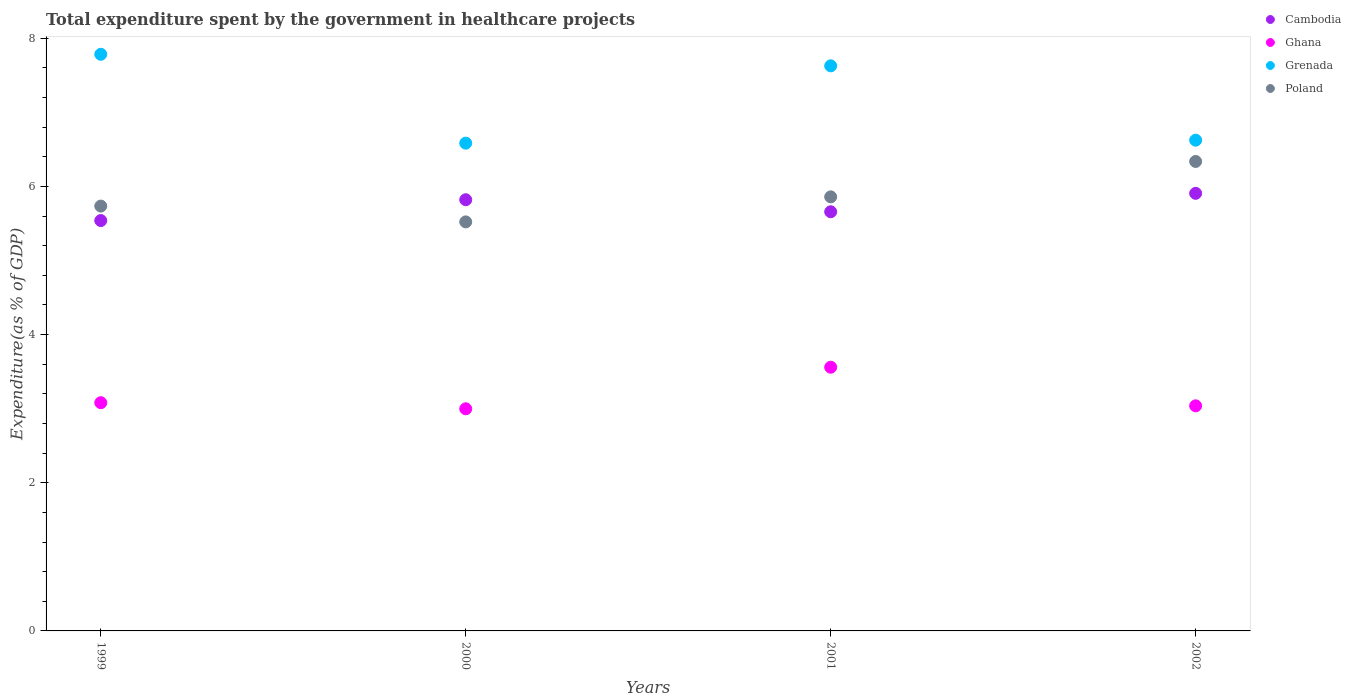How many different coloured dotlines are there?
Your answer should be compact. 4. What is the total expenditure spent by the government in healthcare projects in Ghana in 2001?
Give a very brief answer. 3.56. Across all years, what is the maximum total expenditure spent by the government in healthcare projects in Poland?
Provide a short and direct response. 6.34. Across all years, what is the minimum total expenditure spent by the government in healthcare projects in Poland?
Your answer should be very brief. 5.52. In which year was the total expenditure spent by the government in healthcare projects in Ghana minimum?
Provide a short and direct response. 2000. What is the total total expenditure spent by the government in healthcare projects in Cambodia in the graph?
Keep it short and to the point. 22.92. What is the difference between the total expenditure spent by the government in healthcare projects in Poland in 2001 and that in 2002?
Offer a terse response. -0.48. What is the difference between the total expenditure spent by the government in healthcare projects in Ghana in 1999 and the total expenditure spent by the government in healthcare projects in Grenada in 2000?
Your response must be concise. -3.5. What is the average total expenditure spent by the government in healthcare projects in Ghana per year?
Offer a terse response. 3.17. In the year 2000, what is the difference between the total expenditure spent by the government in healthcare projects in Ghana and total expenditure spent by the government in healthcare projects in Poland?
Make the answer very short. -2.52. In how many years, is the total expenditure spent by the government in healthcare projects in Poland greater than 6.4 %?
Provide a short and direct response. 0. What is the ratio of the total expenditure spent by the government in healthcare projects in Cambodia in 1999 to that in 2001?
Offer a terse response. 0.98. What is the difference between the highest and the second highest total expenditure spent by the government in healthcare projects in Grenada?
Your response must be concise. 0.16. What is the difference between the highest and the lowest total expenditure spent by the government in healthcare projects in Grenada?
Offer a terse response. 1.2. Is it the case that in every year, the sum of the total expenditure spent by the government in healthcare projects in Ghana and total expenditure spent by the government in healthcare projects in Cambodia  is greater than the total expenditure spent by the government in healthcare projects in Poland?
Provide a short and direct response. Yes. Does the total expenditure spent by the government in healthcare projects in Ghana monotonically increase over the years?
Make the answer very short. No. How many dotlines are there?
Your answer should be very brief. 4. How many years are there in the graph?
Your answer should be very brief. 4. What is the difference between two consecutive major ticks on the Y-axis?
Keep it short and to the point. 2. Does the graph contain grids?
Your response must be concise. No. How are the legend labels stacked?
Provide a succinct answer. Vertical. What is the title of the graph?
Provide a succinct answer. Total expenditure spent by the government in healthcare projects. What is the label or title of the Y-axis?
Make the answer very short. Expenditure(as % of GDP). What is the Expenditure(as % of GDP) in Cambodia in 1999?
Make the answer very short. 5.54. What is the Expenditure(as % of GDP) in Ghana in 1999?
Your answer should be very brief. 3.08. What is the Expenditure(as % of GDP) in Grenada in 1999?
Your response must be concise. 7.78. What is the Expenditure(as % of GDP) of Poland in 1999?
Provide a succinct answer. 5.73. What is the Expenditure(as % of GDP) in Cambodia in 2000?
Offer a very short reply. 5.82. What is the Expenditure(as % of GDP) of Ghana in 2000?
Make the answer very short. 3. What is the Expenditure(as % of GDP) in Grenada in 2000?
Make the answer very short. 6.58. What is the Expenditure(as % of GDP) of Poland in 2000?
Provide a succinct answer. 5.52. What is the Expenditure(as % of GDP) in Cambodia in 2001?
Your response must be concise. 5.66. What is the Expenditure(as % of GDP) of Ghana in 2001?
Offer a terse response. 3.56. What is the Expenditure(as % of GDP) of Grenada in 2001?
Your answer should be very brief. 7.63. What is the Expenditure(as % of GDP) of Poland in 2001?
Give a very brief answer. 5.86. What is the Expenditure(as % of GDP) of Cambodia in 2002?
Offer a very short reply. 5.91. What is the Expenditure(as % of GDP) of Ghana in 2002?
Your response must be concise. 3.04. What is the Expenditure(as % of GDP) of Grenada in 2002?
Your answer should be very brief. 6.62. What is the Expenditure(as % of GDP) of Poland in 2002?
Your answer should be very brief. 6.34. Across all years, what is the maximum Expenditure(as % of GDP) in Cambodia?
Offer a terse response. 5.91. Across all years, what is the maximum Expenditure(as % of GDP) in Ghana?
Keep it short and to the point. 3.56. Across all years, what is the maximum Expenditure(as % of GDP) of Grenada?
Keep it short and to the point. 7.78. Across all years, what is the maximum Expenditure(as % of GDP) of Poland?
Keep it short and to the point. 6.34. Across all years, what is the minimum Expenditure(as % of GDP) of Cambodia?
Your response must be concise. 5.54. Across all years, what is the minimum Expenditure(as % of GDP) in Ghana?
Give a very brief answer. 3. Across all years, what is the minimum Expenditure(as % of GDP) in Grenada?
Keep it short and to the point. 6.58. Across all years, what is the minimum Expenditure(as % of GDP) in Poland?
Keep it short and to the point. 5.52. What is the total Expenditure(as % of GDP) in Cambodia in the graph?
Make the answer very short. 22.92. What is the total Expenditure(as % of GDP) in Ghana in the graph?
Your answer should be compact. 12.68. What is the total Expenditure(as % of GDP) of Grenada in the graph?
Offer a very short reply. 28.62. What is the total Expenditure(as % of GDP) in Poland in the graph?
Give a very brief answer. 23.45. What is the difference between the Expenditure(as % of GDP) in Cambodia in 1999 and that in 2000?
Ensure brevity in your answer.  -0.28. What is the difference between the Expenditure(as % of GDP) of Ghana in 1999 and that in 2000?
Provide a succinct answer. 0.08. What is the difference between the Expenditure(as % of GDP) of Grenada in 1999 and that in 2000?
Provide a succinct answer. 1.2. What is the difference between the Expenditure(as % of GDP) of Poland in 1999 and that in 2000?
Provide a short and direct response. 0.21. What is the difference between the Expenditure(as % of GDP) in Cambodia in 1999 and that in 2001?
Your answer should be very brief. -0.12. What is the difference between the Expenditure(as % of GDP) in Ghana in 1999 and that in 2001?
Offer a very short reply. -0.48. What is the difference between the Expenditure(as % of GDP) of Grenada in 1999 and that in 2001?
Your response must be concise. 0.16. What is the difference between the Expenditure(as % of GDP) of Poland in 1999 and that in 2001?
Your answer should be compact. -0.12. What is the difference between the Expenditure(as % of GDP) in Cambodia in 1999 and that in 2002?
Your answer should be very brief. -0.37. What is the difference between the Expenditure(as % of GDP) in Ghana in 1999 and that in 2002?
Your response must be concise. 0.04. What is the difference between the Expenditure(as % of GDP) of Grenada in 1999 and that in 2002?
Make the answer very short. 1.16. What is the difference between the Expenditure(as % of GDP) of Poland in 1999 and that in 2002?
Your answer should be very brief. -0.6. What is the difference between the Expenditure(as % of GDP) in Cambodia in 2000 and that in 2001?
Offer a terse response. 0.16. What is the difference between the Expenditure(as % of GDP) of Ghana in 2000 and that in 2001?
Provide a succinct answer. -0.56. What is the difference between the Expenditure(as % of GDP) of Grenada in 2000 and that in 2001?
Your answer should be very brief. -1.04. What is the difference between the Expenditure(as % of GDP) in Poland in 2000 and that in 2001?
Give a very brief answer. -0.34. What is the difference between the Expenditure(as % of GDP) of Cambodia in 2000 and that in 2002?
Provide a succinct answer. -0.09. What is the difference between the Expenditure(as % of GDP) in Ghana in 2000 and that in 2002?
Your answer should be very brief. -0.04. What is the difference between the Expenditure(as % of GDP) in Grenada in 2000 and that in 2002?
Your answer should be very brief. -0.04. What is the difference between the Expenditure(as % of GDP) of Poland in 2000 and that in 2002?
Your answer should be very brief. -0.82. What is the difference between the Expenditure(as % of GDP) of Cambodia in 2001 and that in 2002?
Keep it short and to the point. -0.25. What is the difference between the Expenditure(as % of GDP) of Ghana in 2001 and that in 2002?
Offer a very short reply. 0.52. What is the difference between the Expenditure(as % of GDP) of Grenada in 2001 and that in 2002?
Offer a very short reply. 1. What is the difference between the Expenditure(as % of GDP) in Poland in 2001 and that in 2002?
Keep it short and to the point. -0.48. What is the difference between the Expenditure(as % of GDP) of Cambodia in 1999 and the Expenditure(as % of GDP) of Ghana in 2000?
Keep it short and to the point. 2.54. What is the difference between the Expenditure(as % of GDP) in Cambodia in 1999 and the Expenditure(as % of GDP) in Grenada in 2000?
Provide a succinct answer. -1.04. What is the difference between the Expenditure(as % of GDP) of Cambodia in 1999 and the Expenditure(as % of GDP) of Poland in 2000?
Your answer should be very brief. 0.02. What is the difference between the Expenditure(as % of GDP) of Ghana in 1999 and the Expenditure(as % of GDP) of Grenada in 2000?
Keep it short and to the point. -3.5. What is the difference between the Expenditure(as % of GDP) of Ghana in 1999 and the Expenditure(as % of GDP) of Poland in 2000?
Offer a terse response. -2.44. What is the difference between the Expenditure(as % of GDP) of Grenada in 1999 and the Expenditure(as % of GDP) of Poland in 2000?
Your response must be concise. 2.26. What is the difference between the Expenditure(as % of GDP) of Cambodia in 1999 and the Expenditure(as % of GDP) of Ghana in 2001?
Ensure brevity in your answer.  1.98. What is the difference between the Expenditure(as % of GDP) in Cambodia in 1999 and the Expenditure(as % of GDP) in Grenada in 2001?
Give a very brief answer. -2.09. What is the difference between the Expenditure(as % of GDP) in Cambodia in 1999 and the Expenditure(as % of GDP) in Poland in 2001?
Offer a terse response. -0.32. What is the difference between the Expenditure(as % of GDP) of Ghana in 1999 and the Expenditure(as % of GDP) of Grenada in 2001?
Offer a very short reply. -4.55. What is the difference between the Expenditure(as % of GDP) of Ghana in 1999 and the Expenditure(as % of GDP) of Poland in 2001?
Make the answer very short. -2.78. What is the difference between the Expenditure(as % of GDP) in Grenada in 1999 and the Expenditure(as % of GDP) in Poland in 2001?
Your answer should be compact. 1.92. What is the difference between the Expenditure(as % of GDP) in Cambodia in 1999 and the Expenditure(as % of GDP) in Ghana in 2002?
Keep it short and to the point. 2.5. What is the difference between the Expenditure(as % of GDP) of Cambodia in 1999 and the Expenditure(as % of GDP) of Grenada in 2002?
Offer a terse response. -1.08. What is the difference between the Expenditure(as % of GDP) of Cambodia in 1999 and the Expenditure(as % of GDP) of Poland in 2002?
Your answer should be compact. -0.8. What is the difference between the Expenditure(as % of GDP) in Ghana in 1999 and the Expenditure(as % of GDP) in Grenada in 2002?
Provide a short and direct response. -3.54. What is the difference between the Expenditure(as % of GDP) in Ghana in 1999 and the Expenditure(as % of GDP) in Poland in 2002?
Your response must be concise. -3.26. What is the difference between the Expenditure(as % of GDP) in Grenada in 1999 and the Expenditure(as % of GDP) in Poland in 2002?
Your response must be concise. 1.45. What is the difference between the Expenditure(as % of GDP) in Cambodia in 2000 and the Expenditure(as % of GDP) in Ghana in 2001?
Offer a very short reply. 2.26. What is the difference between the Expenditure(as % of GDP) in Cambodia in 2000 and the Expenditure(as % of GDP) in Grenada in 2001?
Your answer should be compact. -1.81. What is the difference between the Expenditure(as % of GDP) in Cambodia in 2000 and the Expenditure(as % of GDP) in Poland in 2001?
Your answer should be compact. -0.04. What is the difference between the Expenditure(as % of GDP) in Ghana in 2000 and the Expenditure(as % of GDP) in Grenada in 2001?
Your answer should be compact. -4.63. What is the difference between the Expenditure(as % of GDP) of Ghana in 2000 and the Expenditure(as % of GDP) of Poland in 2001?
Your answer should be compact. -2.86. What is the difference between the Expenditure(as % of GDP) in Grenada in 2000 and the Expenditure(as % of GDP) in Poland in 2001?
Your response must be concise. 0.72. What is the difference between the Expenditure(as % of GDP) of Cambodia in 2000 and the Expenditure(as % of GDP) of Ghana in 2002?
Offer a terse response. 2.78. What is the difference between the Expenditure(as % of GDP) of Cambodia in 2000 and the Expenditure(as % of GDP) of Grenada in 2002?
Make the answer very short. -0.8. What is the difference between the Expenditure(as % of GDP) in Cambodia in 2000 and the Expenditure(as % of GDP) in Poland in 2002?
Give a very brief answer. -0.52. What is the difference between the Expenditure(as % of GDP) in Ghana in 2000 and the Expenditure(as % of GDP) in Grenada in 2002?
Provide a short and direct response. -3.63. What is the difference between the Expenditure(as % of GDP) in Ghana in 2000 and the Expenditure(as % of GDP) in Poland in 2002?
Provide a short and direct response. -3.34. What is the difference between the Expenditure(as % of GDP) of Grenada in 2000 and the Expenditure(as % of GDP) of Poland in 2002?
Your response must be concise. 0.25. What is the difference between the Expenditure(as % of GDP) in Cambodia in 2001 and the Expenditure(as % of GDP) in Ghana in 2002?
Offer a very short reply. 2.62. What is the difference between the Expenditure(as % of GDP) of Cambodia in 2001 and the Expenditure(as % of GDP) of Grenada in 2002?
Offer a terse response. -0.97. What is the difference between the Expenditure(as % of GDP) of Cambodia in 2001 and the Expenditure(as % of GDP) of Poland in 2002?
Give a very brief answer. -0.68. What is the difference between the Expenditure(as % of GDP) in Ghana in 2001 and the Expenditure(as % of GDP) in Grenada in 2002?
Give a very brief answer. -3.06. What is the difference between the Expenditure(as % of GDP) of Ghana in 2001 and the Expenditure(as % of GDP) of Poland in 2002?
Keep it short and to the point. -2.78. What is the difference between the Expenditure(as % of GDP) in Grenada in 2001 and the Expenditure(as % of GDP) in Poland in 2002?
Provide a succinct answer. 1.29. What is the average Expenditure(as % of GDP) in Cambodia per year?
Ensure brevity in your answer.  5.73. What is the average Expenditure(as % of GDP) in Ghana per year?
Offer a very short reply. 3.17. What is the average Expenditure(as % of GDP) of Grenada per year?
Your answer should be compact. 7.15. What is the average Expenditure(as % of GDP) in Poland per year?
Offer a very short reply. 5.86. In the year 1999, what is the difference between the Expenditure(as % of GDP) of Cambodia and Expenditure(as % of GDP) of Ghana?
Provide a succinct answer. 2.46. In the year 1999, what is the difference between the Expenditure(as % of GDP) of Cambodia and Expenditure(as % of GDP) of Grenada?
Ensure brevity in your answer.  -2.24. In the year 1999, what is the difference between the Expenditure(as % of GDP) of Cambodia and Expenditure(as % of GDP) of Poland?
Provide a succinct answer. -0.2. In the year 1999, what is the difference between the Expenditure(as % of GDP) in Ghana and Expenditure(as % of GDP) in Grenada?
Your answer should be compact. -4.7. In the year 1999, what is the difference between the Expenditure(as % of GDP) in Ghana and Expenditure(as % of GDP) in Poland?
Your answer should be very brief. -2.65. In the year 1999, what is the difference between the Expenditure(as % of GDP) of Grenada and Expenditure(as % of GDP) of Poland?
Make the answer very short. 2.05. In the year 2000, what is the difference between the Expenditure(as % of GDP) in Cambodia and Expenditure(as % of GDP) in Ghana?
Provide a succinct answer. 2.82. In the year 2000, what is the difference between the Expenditure(as % of GDP) of Cambodia and Expenditure(as % of GDP) of Grenada?
Provide a succinct answer. -0.76. In the year 2000, what is the difference between the Expenditure(as % of GDP) of Cambodia and Expenditure(as % of GDP) of Poland?
Your answer should be very brief. 0.3. In the year 2000, what is the difference between the Expenditure(as % of GDP) in Ghana and Expenditure(as % of GDP) in Grenada?
Offer a terse response. -3.59. In the year 2000, what is the difference between the Expenditure(as % of GDP) in Ghana and Expenditure(as % of GDP) in Poland?
Your answer should be compact. -2.52. In the year 2000, what is the difference between the Expenditure(as % of GDP) in Grenada and Expenditure(as % of GDP) in Poland?
Ensure brevity in your answer.  1.06. In the year 2001, what is the difference between the Expenditure(as % of GDP) of Cambodia and Expenditure(as % of GDP) of Ghana?
Provide a short and direct response. 2.1. In the year 2001, what is the difference between the Expenditure(as % of GDP) in Cambodia and Expenditure(as % of GDP) in Grenada?
Your answer should be very brief. -1.97. In the year 2001, what is the difference between the Expenditure(as % of GDP) in Cambodia and Expenditure(as % of GDP) in Poland?
Your response must be concise. -0.2. In the year 2001, what is the difference between the Expenditure(as % of GDP) in Ghana and Expenditure(as % of GDP) in Grenada?
Offer a terse response. -4.07. In the year 2001, what is the difference between the Expenditure(as % of GDP) in Ghana and Expenditure(as % of GDP) in Poland?
Your answer should be very brief. -2.3. In the year 2001, what is the difference between the Expenditure(as % of GDP) in Grenada and Expenditure(as % of GDP) in Poland?
Give a very brief answer. 1.77. In the year 2002, what is the difference between the Expenditure(as % of GDP) of Cambodia and Expenditure(as % of GDP) of Ghana?
Your answer should be compact. 2.87. In the year 2002, what is the difference between the Expenditure(as % of GDP) of Cambodia and Expenditure(as % of GDP) of Grenada?
Offer a terse response. -0.72. In the year 2002, what is the difference between the Expenditure(as % of GDP) in Cambodia and Expenditure(as % of GDP) in Poland?
Provide a short and direct response. -0.43. In the year 2002, what is the difference between the Expenditure(as % of GDP) in Ghana and Expenditure(as % of GDP) in Grenada?
Ensure brevity in your answer.  -3.59. In the year 2002, what is the difference between the Expenditure(as % of GDP) of Ghana and Expenditure(as % of GDP) of Poland?
Offer a very short reply. -3.3. In the year 2002, what is the difference between the Expenditure(as % of GDP) of Grenada and Expenditure(as % of GDP) of Poland?
Offer a very short reply. 0.29. What is the ratio of the Expenditure(as % of GDP) of Cambodia in 1999 to that in 2000?
Offer a terse response. 0.95. What is the ratio of the Expenditure(as % of GDP) of Ghana in 1999 to that in 2000?
Provide a short and direct response. 1.03. What is the ratio of the Expenditure(as % of GDP) of Grenada in 1999 to that in 2000?
Keep it short and to the point. 1.18. What is the ratio of the Expenditure(as % of GDP) of Poland in 1999 to that in 2000?
Provide a succinct answer. 1.04. What is the ratio of the Expenditure(as % of GDP) of Cambodia in 1999 to that in 2001?
Offer a terse response. 0.98. What is the ratio of the Expenditure(as % of GDP) in Ghana in 1999 to that in 2001?
Provide a short and direct response. 0.87. What is the ratio of the Expenditure(as % of GDP) of Grenada in 1999 to that in 2001?
Provide a succinct answer. 1.02. What is the ratio of the Expenditure(as % of GDP) of Poland in 1999 to that in 2001?
Offer a terse response. 0.98. What is the ratio of the Expenditure(as % of GDP) of Cambodia in 1999 to that in 2002?
Your response must be concise. 0.94. What is the ratio of the Expenditure(as % of GDP) in Ghana in 1999 to that in 2002?
Your answer should be very brief. 1.01. What is the ratio of the Expenditure(as % of GDP) in Grenada in 1999 to that in 2002?
Offer a terse response. 1.18. What is the ratio of the Expenditure(as % of GDP) in Poland in 1999 to that in 2002?
Your answer should be very brief. 0.91. What is the ratio of the Expenditure(as % of GDP) in Cambodia in 2000 to that in 2001?
Give a very brief answer. 1.03. What is the ratio of the Expenditure(as % of GDP) of Ghana in 2000 to that in 2001?
Provide a succinct answer. 0.84. What is the ratio of the Expenditure(as % of GDP) in Grenada in 2000 to that in 2001?
Your response must be concise. 0.86. What is the ratio of the Expenditure(as % of GDP) in Poland in 2000 to that in 2001?
Provide a short and direct response. 0.94. What is the ratio of the Expenditure(as % of GDP) of Cambodia in 2000 to that in 2002?
Keep it short and to the point. 0.99. What is the ratio of the Expenditure(as % of GDP) of Ghana in 2000 to that in 2002?
Ensure brevity in your answer.  0.99. What is the ratio of the Expenditure(as % of GDP) in Grenada in 2000 to that in 2002?
Give a very brief answer. 0.99. What is the ratio of the Expenditure(as % of GDP) of Poland in 2000 to that in 2002?
Make the answer very short. 0.87. What is the ratio of the Expenditure(as % of GDP) of Cambodia in 2001 to that in 2002?
Your answer should be compact. 0.96. What is the ratio of the Expenditure(as % of GDP) of Ghana in 2001 to that in 2002?
Offer a terse response. 1.17. What is the ratio of the Expenditure(as % of GDP) of Grenada in 2001 to that in 2002?
Offer a terse response. 1.15. What is the ratio of the Expenditure(as % of GDP) in Poland in 2001 to that in 2002?
Provide a succinct answer. 0.92. What is the difference between the highest and the second highest Expenditure(as % of GDP) in Cambodia?
Provide a short and direct response. 0.09. What is the difference between the highest and the second highest Expenditure(as % of GDP) in Ghana?
Your response must be concise. 0.48. What is the difference between the highest and the second highest Expenditure(as % of GDP) in Grenada?
Provide a succinct answer. 0.16. What is the difference between the highest and the second highest Expenditure(as % of GDP) in Poland?
Your answer should be compact. 0.48. What is the difference between the highest and the lowest Expenditure(as % of GDP) of Cambodia?
Provide a succinct answer. 0.37. What is the difference between the highest and the lowest Expenditure(as % of GDP) in Ghana?
Your answer should be very brief. 0.56. What is the difference between the highest and the lowest Expenditure(as % of GDP) of Grenada?
Offer a very short reply. 1.2. What is the difference between the highest and the lowest Expenditure(as % of GDP) in Poland?
Your response must be concise. 0.82. 